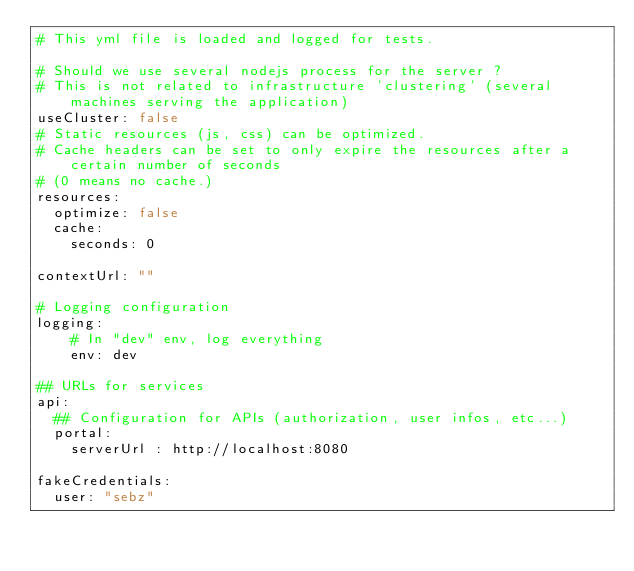<code> <loc_0><loc_0><loc_500><loc_500><_YAML_># This yml file is loaded and logged for tests.

# Should we use several nodejs process for the server ?
# This is not related to infrastructure 'clustering' (several machines serving the application)
useCluster: false
# Static resources (js, css) can be optimized.
# Cache headers can be set to only expire the resources after a certain number of seconds
# (0 means no cache.)
resources:
  optimize: false
  cache:
    seconds: 0

contextUrl: ""

# Logging configuration
logging:
    # In "dev" env, log everything
    env: dev

## URLs for services
api:
  ## Configuration for APIs (authorization, user infos, etc...)
  portal:
    serverUrl : http://localhost:8080

fakeCredentials:
  user: "sebz"</code> 